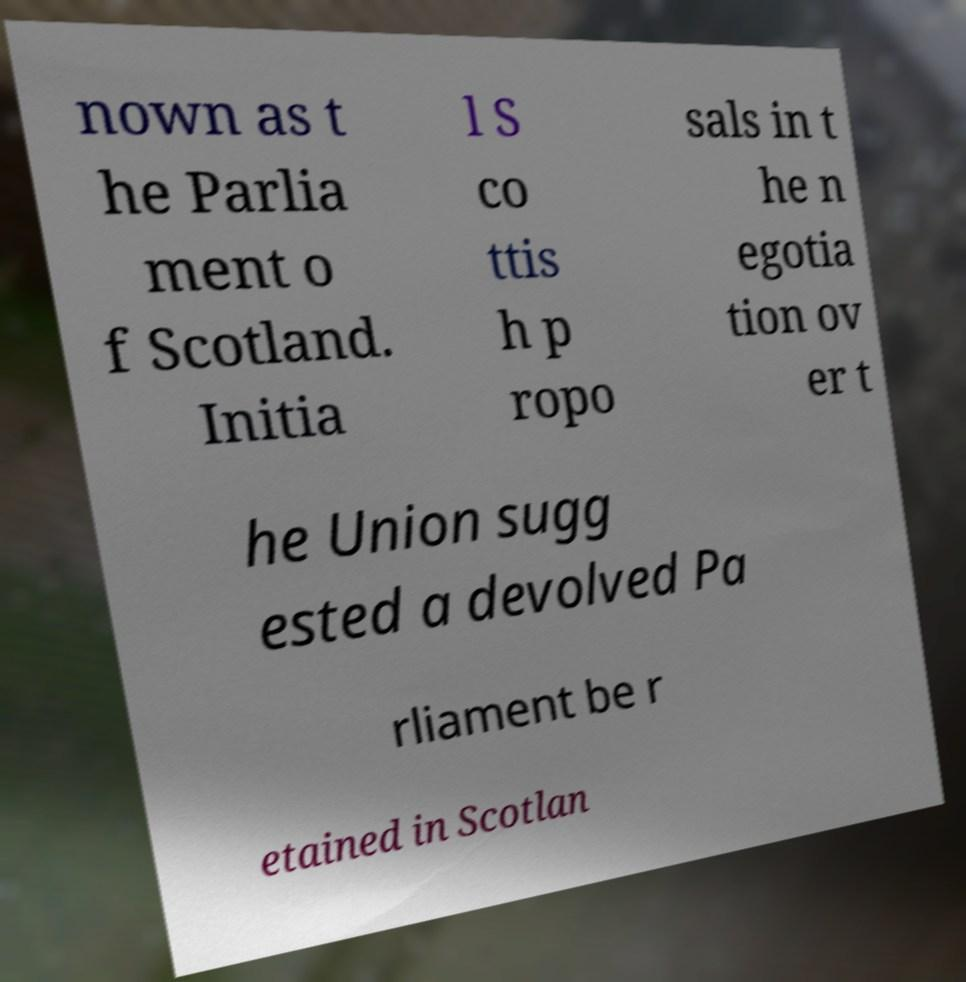Please identify and transcribe the text found in this image. nown as t he Parlia ment o f Scotland. Initia l S co ttis h p ropo sals in t he n egotia tion ov er t he Union sugg ested a devolved Pa rliament be r etained in Scotlan 